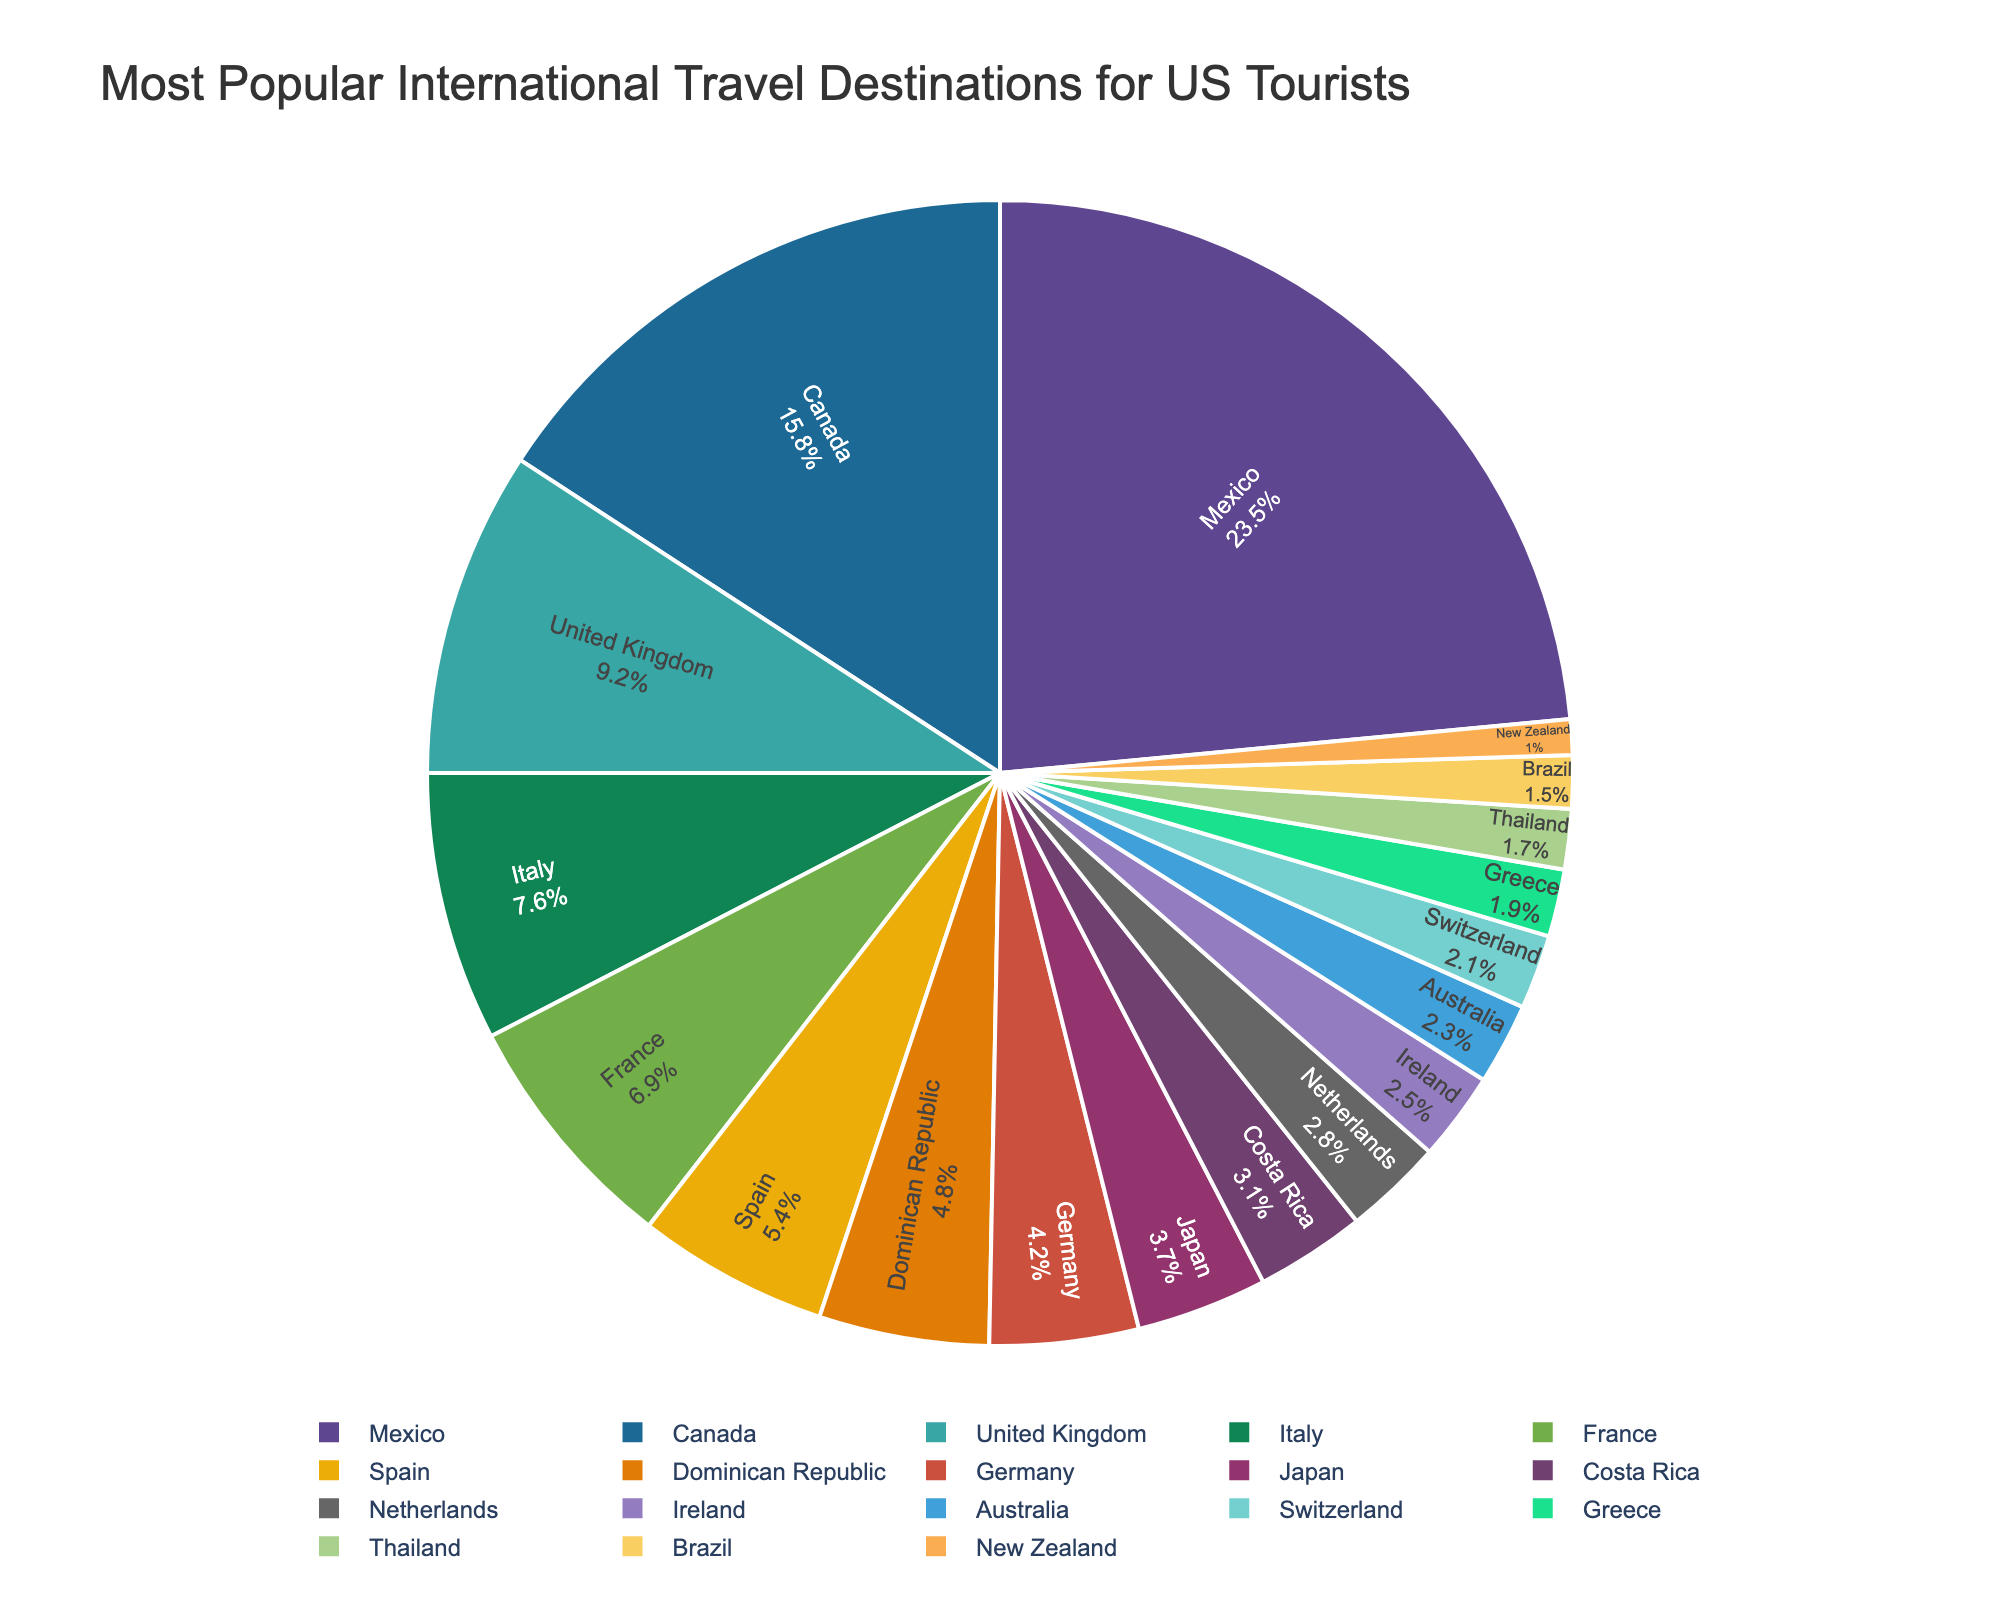Which destination is the most popular among US tourists? The largest wedge in the pie chart corresponds to the most popular destination.
Answer: Mexico Which destination has the smallest percentage of US tourists? The smallest wedge in the pie chart corresponds to the least popular destination.
Answer: New Zealand What is the combined percentage of US tourists traveling to Italy, France, and Spain? Sum the percentages for Italy (7.6%), France (6.9%), and Spain (5.4%): 7.6 + 6.9 + 5.4 = 19.9%.
Answer: 19.9% Is the percentage of US tourists traveling to Canada greater than the percentage of those traveling to the United Kingdom and Italy combined? Sum the percentages for the United Kingdom (9.2%) and Italy (7.6%): 9.2 + 7.6 = 16.8%. Compare 15.8% (Canada) with 16.8%: 15.8 < 16.8.
Answer: No Which destinations have a popularity percentage between Japan and Dominican Republic? Check the percentages between Japan (3.7%) and Dominican Republic (4.8%). The country in between is Germany at 4.2%.
Answer: Germany What percentage of US tourists travel to destinations other than Mexico and Canada combined? Sum the percentages of Mexico (23.5%) and Canada (15.8%): 23.5 + 15.8 = 39.3%. Subtract this from 100%: 100 - 39.3 = 60.7%.
Answer: 60.7% Are there more US tourists traveling to the United Kingdom than to Italy and France combined? Sum the percentages for Italy (7.6%) and France (6.9%): 7.6 + 6.9 = 14.5%. Compare this with the United Kingdom (9.2%): 9.2 < 14.5.
Answer: No Which destinations have percentages within the top 5? The top 5 destinations by percentage are: Mexico (23.5%), Canada (15.8%), United Kingdom (9.2%), Italy (7.6%), and France (6.9%).
Answer: Mexico, Canada, United Kingdom, Italy, France 